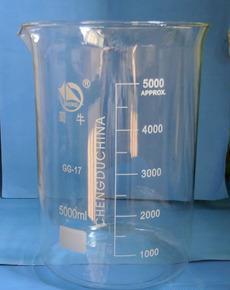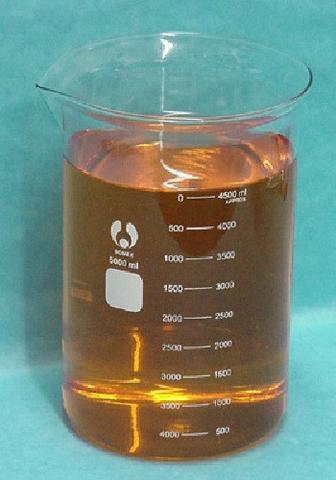The first image is the image on the left, the second image is the image on the right. For the images displayed, is the sentence "One of the images contains a flask rather than a beaker." factually correct? Answer yes or no. No. The first image is the image on the left, the second image is the image on the right. Given the left and right images, does the statement "One of the images shows an empty flask and the other image shows a flask containing liquid." hold true? Answer yes or no. Yes. 